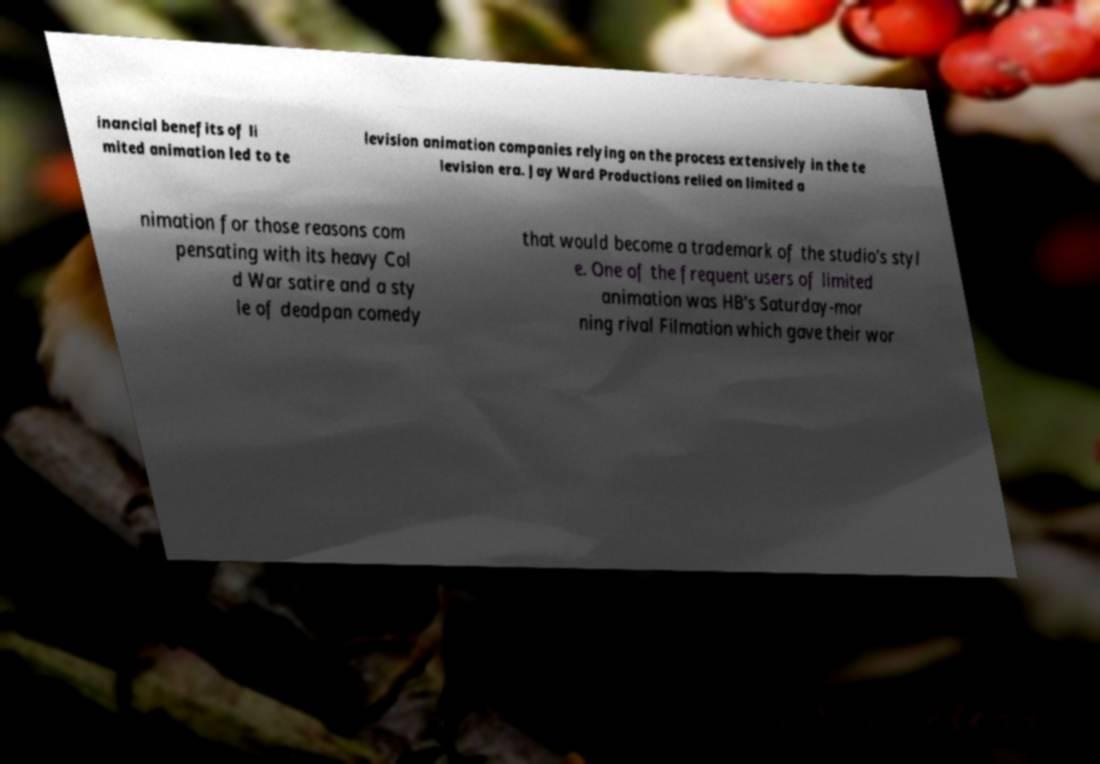I need the written content from this picture converted into text. Can you do that? inancial benefits of li mited animation led to te levision animation companies relying on the process extensively in the te levision era. Jay Ward Productions relied on limited a nimation for those reasons com pensating with its heavy Col d War satire and a sty le of deadpan comedy that would become a trademark of the studio's styl e. One of the frequent users of limited animation was HB's Saturday-mor ning rival Filmation which gave their wor 